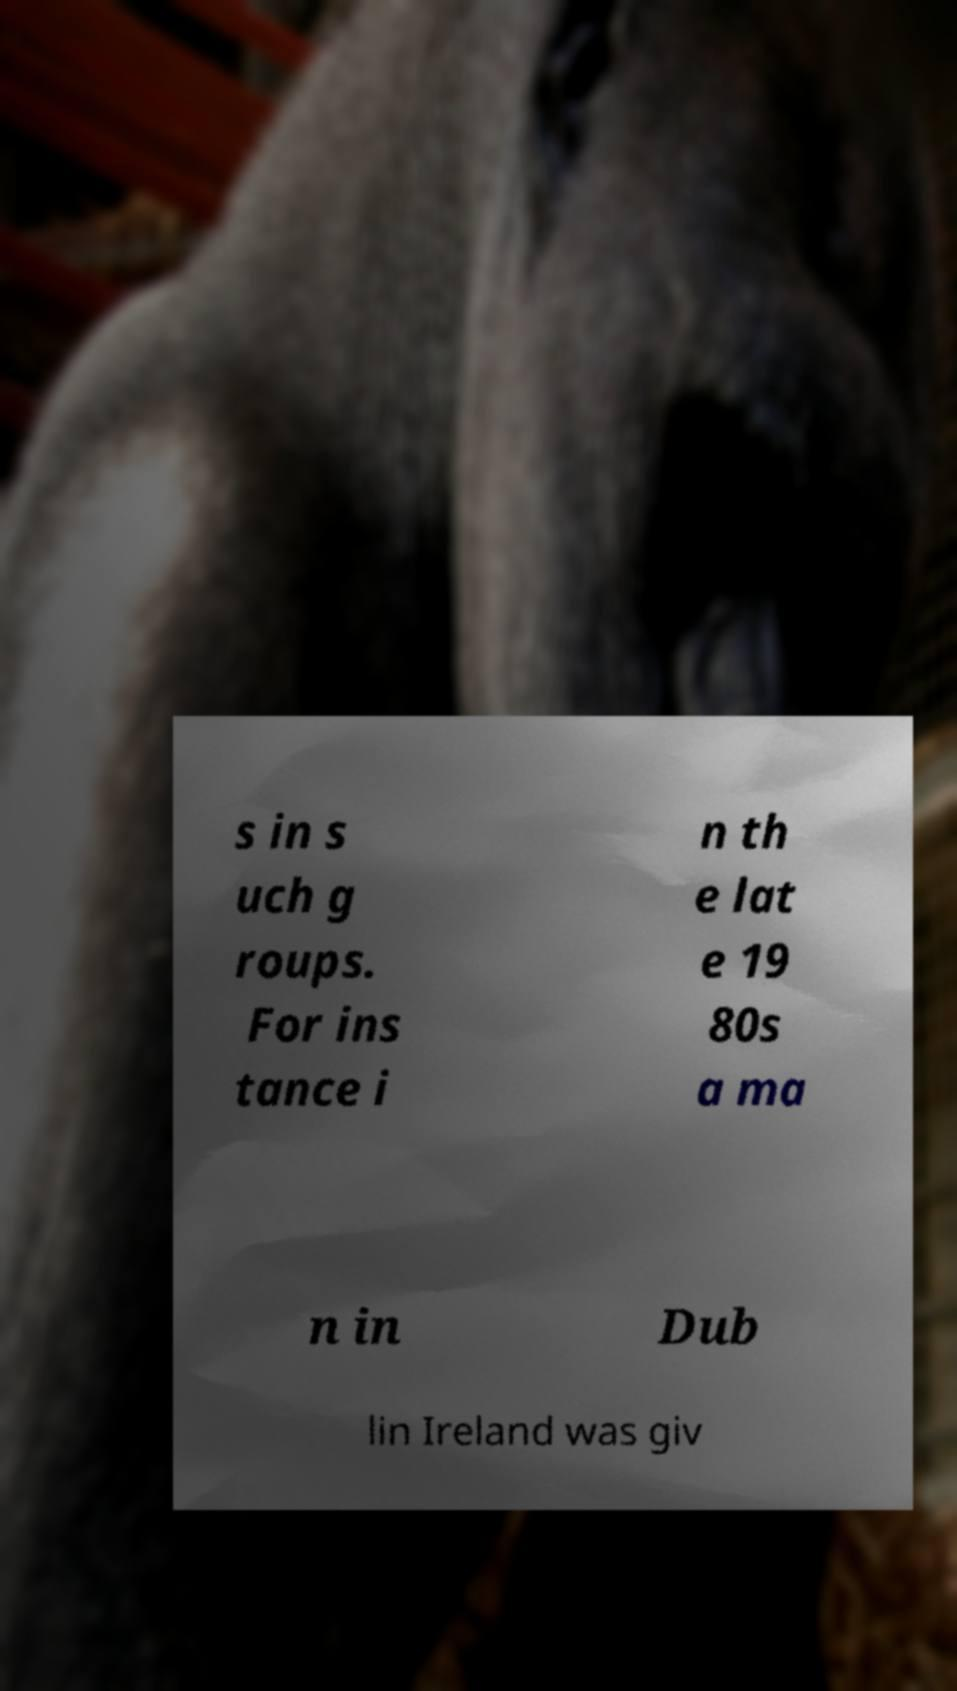I need the written content from this picture converted into text. Can you do that? s in s uch g roups. For ins tance i n th e lat e 19 80s a ma n in Dub lin Ireland was giv 